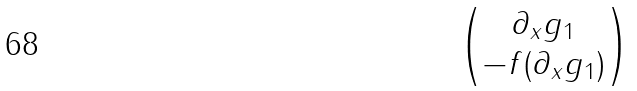Convert formula to latex. <formula><loc_0><loc_0><loc_500><loc_500>\begin{pmatrix} \partial _ { x } g _ { 1 } \\ - f ( \partial _ { x } g _ { 1 } ) \end{pmatrix}</formula> 